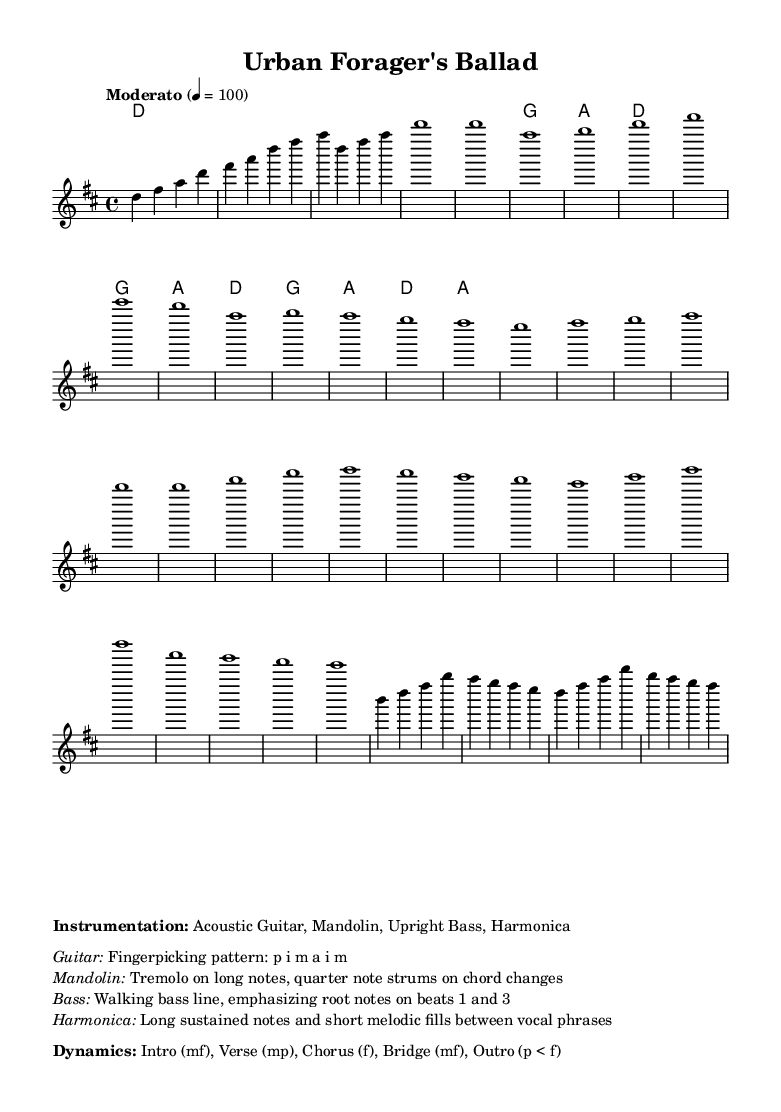What is the key signature of this music? The key signature is D major, which has two sharps (F# and C#). This can be identified at the beginning of the sheet music, typically indicated next to the clef.
Answer: D major What is the time signature of the piece? The time signature is 4/4, which indicates there are four beats in each measure and a quarter note receives one beat. This information is also given at the beginning of the sheet music.
Answer: 4/4 What is the tempo marking of this piece? The tempo marking is "Moderato," which suggests a moderate speed. It is noted within the score next to the tempo indication.
Answer: Moderato Which instrument is specifically noted for playing a walking bass line? The Upright Bass is noted to play a walking bass line, which generally emphasizes the root notes on beats 1 and 3. This can be found in the instrumentation section of the markup.
Answer: Upright Bass What dynamics are indicated for the chorus section? The dynamics for the chorus are indicated as "f," meaning forte, which suggests playing loudly. In the given dynamics specification, expressions such as "mf" for moderate and "f" for loud can typically be seen marked within the score.
Answer: f What type of strumming pattern is used by the mandolin? The mandolin uses a tremolo on long notes and quarter note strums on chord changes, as described in the instrumentation details.
Answer: Tremolo Which section follows the chorus in this piece? The piece transitions into the Bridge section following the chorus, denoted in the structure of the music shown in the melody line.
Answer: Bridge 